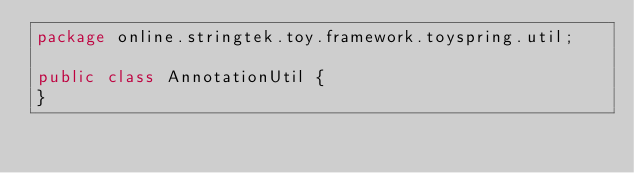<code> <loc_0><loc_0><loc_500><loc_500><_Java_>package online.stringtek.toy.framework.toyspring.util;

public class AnnotationUtil {
}
</code> 